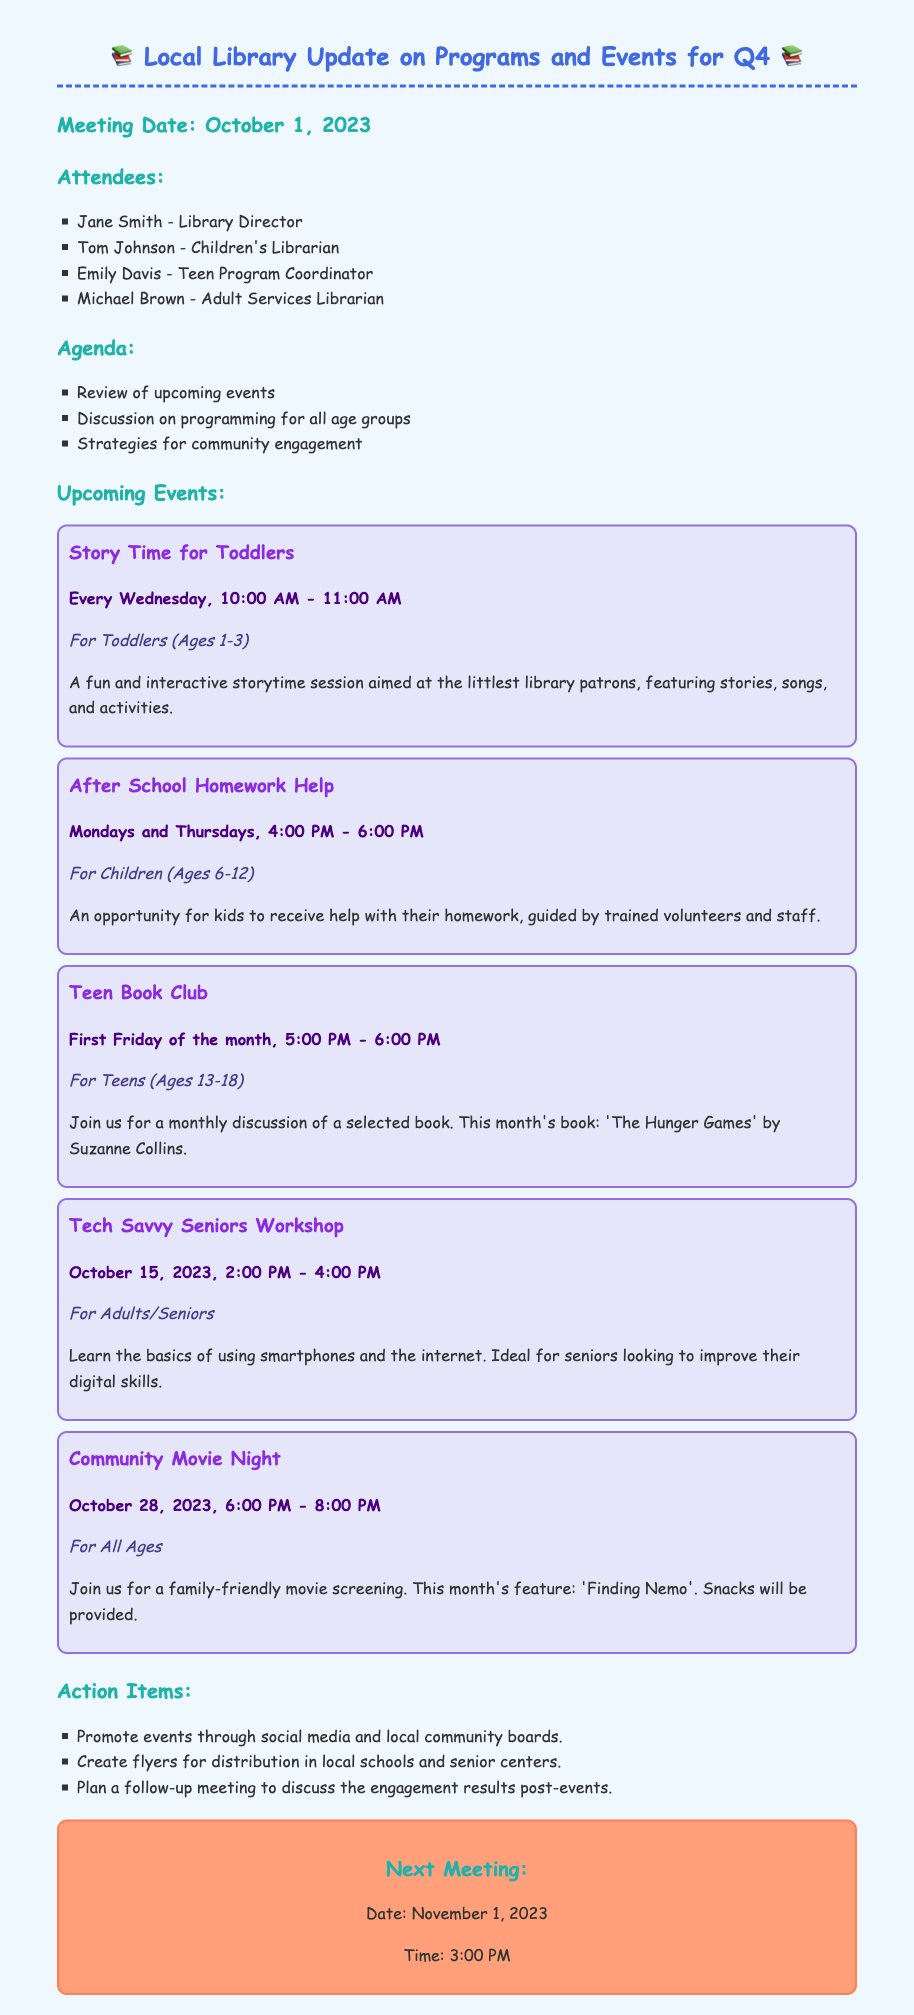What is the meeting date? The meeting date is mentioned in the document under the heading "Meeting Date."
Answer: October 1, 2023 Who is the Children's Librarian? The name of the Children's Librarian is listed in the attendees section.
Answer: Tom Johnson What day and time is the Community Movie Night? The day and time for the Community Movie Night can be found in the upcoming events section.
Answer: October 28, 2023, 6:00 PM - 8:00 PM How often does the Teen Book Club meet? The frequency of the Teen Book Club is specified in the events section.
Answer: First Friday of the month What is the age group for the Tech Savvy Seniors Workshop? The age group for the Tech Savvy Seniors Workshop is indicated directly in the event description.
Answer: For Adults/Seniors Which event is suitable for toddlers? The event suitable for toddlers is specifically mentioned in the events section, focusing on their age group.
Answer: Story Time for Toddlers What is the next meeting date? The next meeting date is stated at the bottom of the document.
Answer: November 1, 2023 How many action items are listed in the document? The number of action items can be counted directly from the action items section.
Answer: Three 